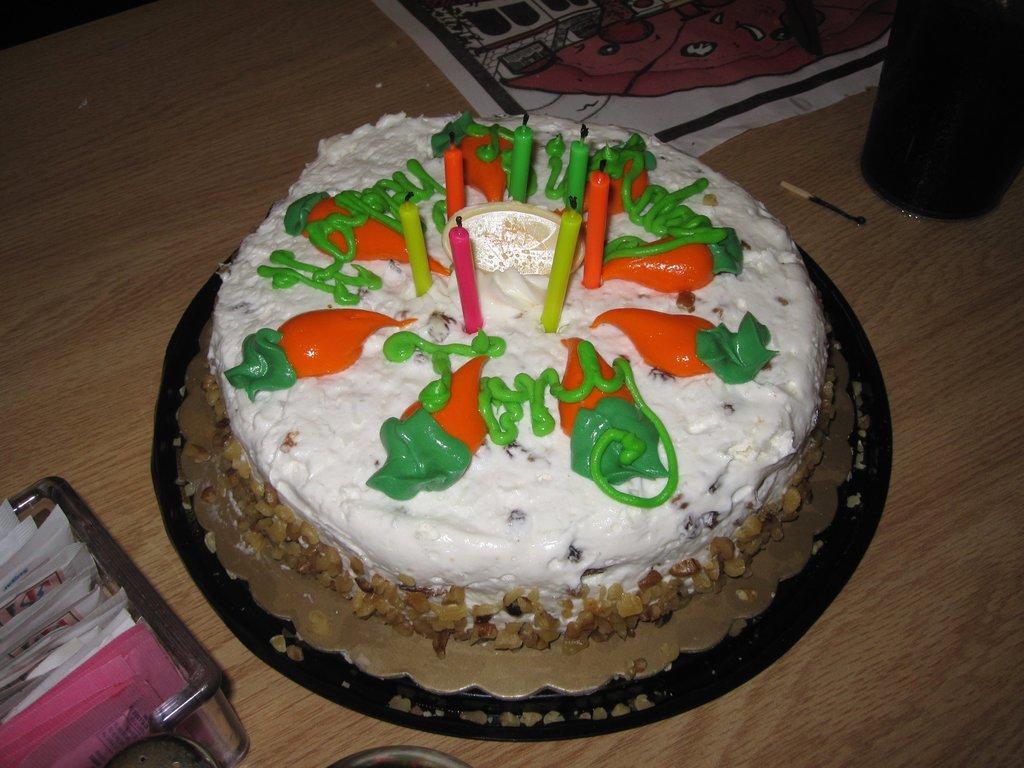Could you give a brief overview of what you see in this image? In this image there is a birthday cake on table beside that there is a table mat, match stick, cup and tray with some papers. 